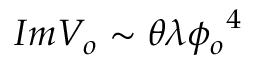Convert formula to latex. <formula><loc_0><loc_0><loc_500><loc_500>I m V _ { o } \sim \theta \lambda { \phi _ { o } } ^ { 4 }</formula> 